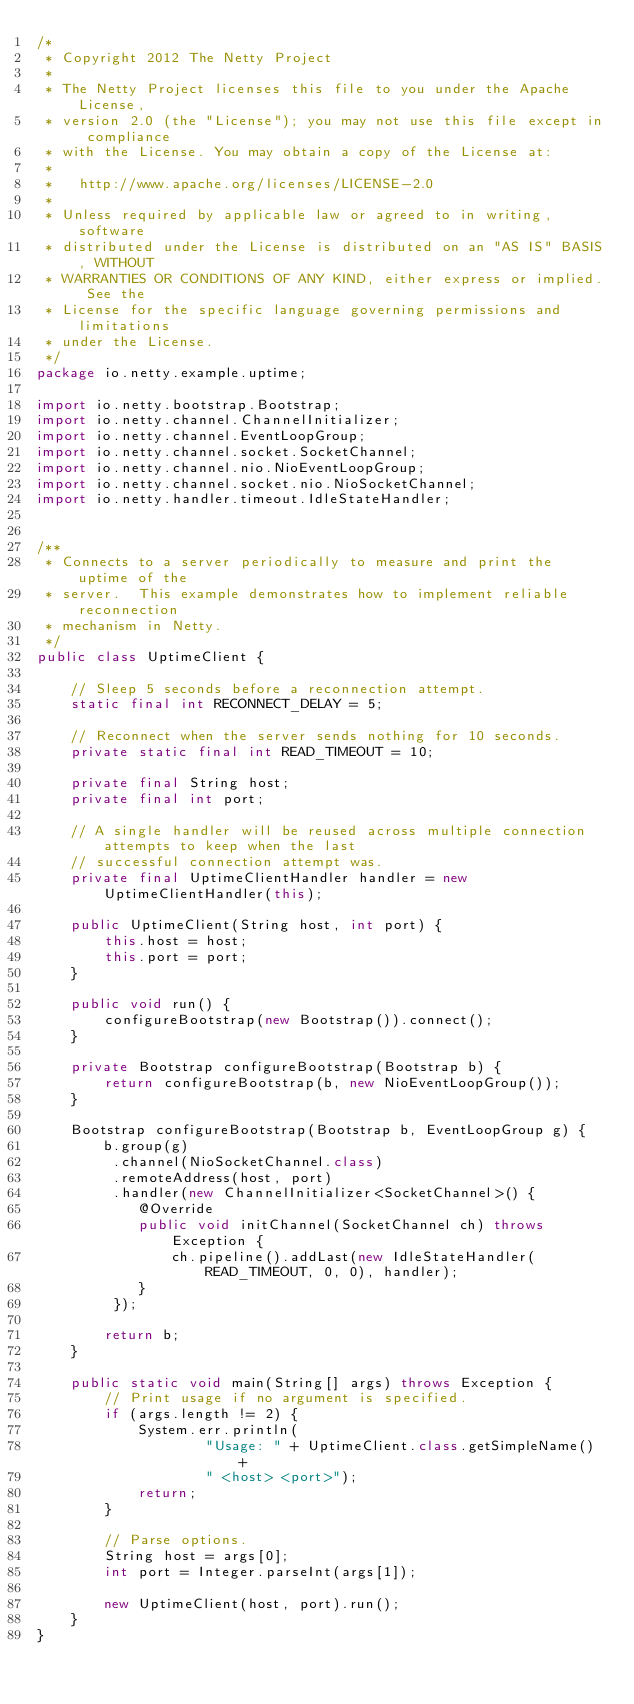Convert code to text. <code><loc_0><loc_0><loc_500><loc_500><_Java_>/*
 * Copyright 2012 The Netty Project
 *
 * The Netty Project licenses this file to you under the Apache License,
 * version 2.0 (the "License"); you may not use this file except in compliance
 * with the License. You may obtain a copy of the License at:
 *
 *   http://www.apache.org/licenses/LICENSE-2.0
 *
 * Unless required by applicable law or agreed to in writing, software
 * distributed under the License is distributed on an "AS IS" BASIS, WITHOUT
 * WARRANTIES OR CONDITIONS OF ANY KIND, either express or implied. See the
 * License for the specific language governing permissions and limitations
 * under the License.
 */
package io.netty.example.uptime;

import io.netty.bootstrap.Bootstrap;
import io.netty.channel.ChannelInitializer;
import io.netty.channel.EventLoopGroup;
import io.netty.channel.socket.SocketChannel;
import io.netty.channel.nio.NioEventLoopGroup;
import io.netty.channel.socket.nio.NioSocketChannel;
import io.netty.handler.timeout.IdleStateHandler;


/**
 * Connects to a server periodically to measure and print the uptime of the
 * server.  This example demonstrates how to implement reliable reconnection
 * mechanism in Netty.
 */
public class UptimeClient {

    // Sleep 5 seconds before a reconnection attempt.
    static final int RECONNECT_DELAY = 5;

    // Reconnect when the server sends nothing for 10 seconds.
    private static final int READ_TIMEOUT = 10;

    private final String host;
    private final int port;

    // A single handler will be reused across multiple connection attempts to keep when the last
    // successful connection attempt was.
    private final UptimeClientHandler handler = new UptimeClientHandler(this);

    public UptimeClient(String host, int port) {
        this.host = host;
        this.port = port;
    }

    public void run() {
        configureBootstrap(new Bootstrap()).connect();
    }

    private Bootstrap configureBootstrap(Bootstrap b) {
        return configureBootstrap(b, new NioEventLoopGroup());
    }

    Bootstrap configureBootstrap(Bootstrap b, EventLoopGroup g) {
        b.group(g)
         .channel(NioSocketChannel.class)
         .remoteAddress(host, port)
         .handler(new ChannelInitializer<SocketChannel>() {
            @Override
            public void initChannel(SocketChannel ch) throws Exception {
                ch.pipeline().addLast(new IdleStateHandler(READ_TIMEOUT, 0, 0), handler);
            }
         });

        return b;
    }

    public static void main(String[] args) throws Exception {
        // Print usage if no argument is specified.
        if (args.length != 2) {
            System.err.println(
                    "Usage: " + UptimeClient.class.getSimpleName() +
                    " <host> <port>");
            return;
        }

        // Parse options.
        String host = args[0];
        int port = Integer.parseInt(args[1]);

        new UptimeClient(host, port).run();
    }
}
</code> 